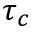<formula> <loc_0><loc_0><loc_500><loc_500>\tau _ { c }</formula> 